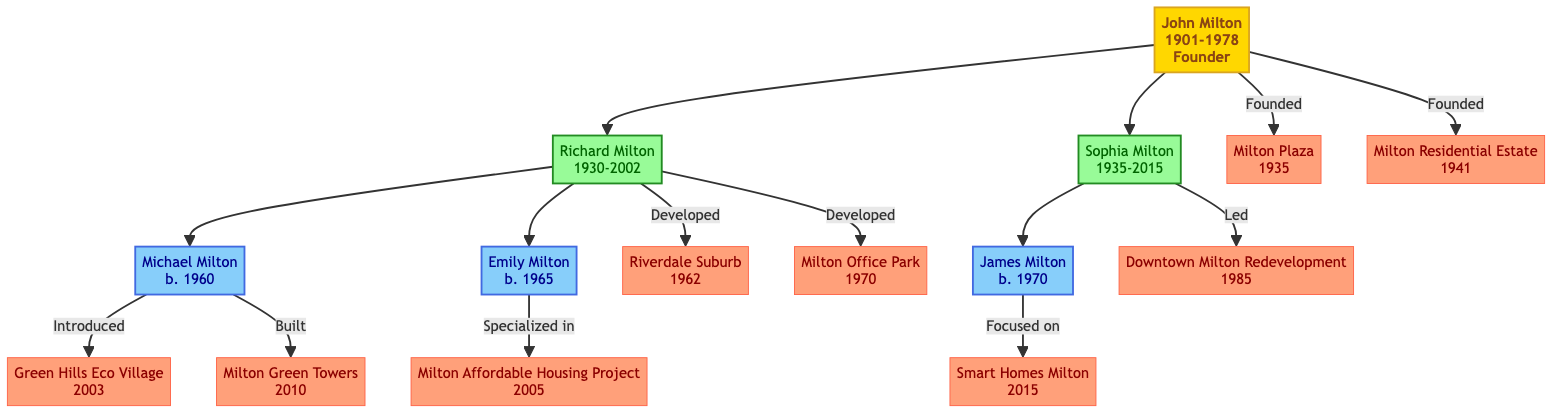What is the birth year of John Milton? According to the diagram, John Milton is noted to have been born in the year 1901.
Answer: 1901 How many key projects did Richard Milton contribute to? The diagram shows that Richard Milton is associated with two key projects: Riverdale Suburb and Milton Office Park.
Answer: 2 What type of project did Sophia Milton lead in 1985? The diagram indicates that Sophia Milton led a project titled Downtown Milton Redevelopment in the year 1985, categorized as a Mixed-Use project.
Answer: Mixed-Use Who is the parent of Michael Milton? The diagram shows that Michael Milton is the son of Richard Milton.
Answer: Richard Milton Which grandchild focused on tech integration in housing? The diagram indicates that James Milton, the son of Sophia Milton, focused on tech integration in housing through his project Smart Homes Milton.
Answer: James Milton What year did the Milton Affordable Housing Project take place? According to the diagram, the Milton Affordable Housing Project was initiated in the year 2005.
Answer: 2005 Which generation did Milton Green Towers fall under? The diagram categorizes Milton Green Towers as a project associated with the third generation member, Michael Milton.
Answer: Third Generation What type of contribution did Emily Milton specialize in? The diagram specifies that Emily Milton specialized in affordable housing projects, particularly through her key project, the Milton Affordable Housing Project.
Answer: Affordable Housing How many nodes represent the second generation in this diagram? The diagram includes two members of the second generation: Richard Milton and Sophia Milton, hence the total number of nodes in this generation is two.
Answer: 2 